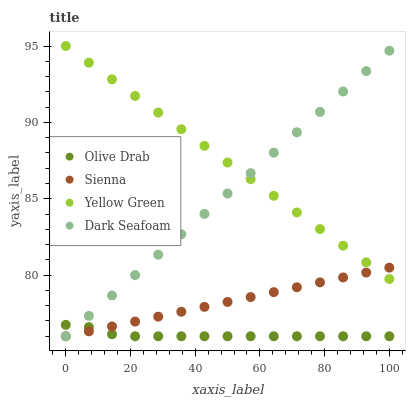Does Olive Drab have the minimum area under the curve?
Answer yes or no. Yes. Does Yellow Green have the maximum area under the curve?
Answer yes or no. Yes. Does Dark Seafoam have the minimum area under the curve?
Answer yes or no. No. Does Dark Seafoam have the maximum area under the curve?
Answer yes or no. No. Is Dark Seafoam the smoothest?
Answer yes or no. Yes. Is Olive Drab the roughest?
Answer yes or no. Yes. Is Yellow Green the smoothest?
Answer yes or no. No. Is Yellow Green the roughest?
Answer yes or no. No. Does Sienna have the lowest value?
Answer yes or no. Yes. Does Yellow Green have the lowest value?
Answer yes or no. No. Does Yellow Green have the highest value?
Answer yes or no. Yes. Does Dark Seafoam have the highest value?
Answer yes or no. No. Is Olive Drab less than Yellow Green?
Answer yes or no. Yes. Is Yellow Green greater than Olive Drab?
Answer yes or no. Yes. Does Sienna intersect Yellow Green?
Answer yes or no. Yes. Is Sienna less than Yellow Green?
Answer yes or no. No. Is Sienna greater than Yellow Green?
Answer yes or no. No. Does Olive Drab intersect Yellow Green?
Answer yes or no. No. 